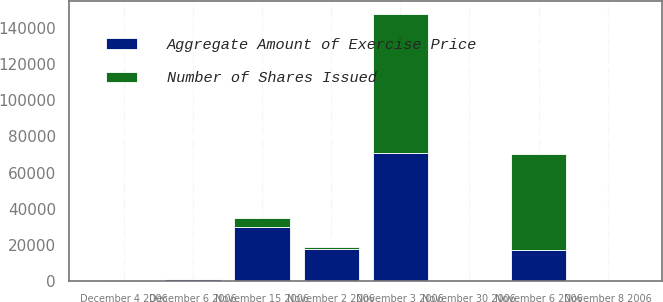<chart> <loc_0><loc_0><loc_500><loc_500><stacked_bar_chart><ecel><fcel>November 2 2006<fcel>November 3 2006<fcel>November 6 2006<fcel>November 8 2006<fcel>November 15 2006<fcel>November 30 2006<fcel>December 4 2006<fcel>December 6 2006<nl><fcel>Aggregate Amount of Exercise Price<fcel>17550<fcel>70750<fcel>17000<fcel>25<fcel>30000<fcel>500<fcel>100<fcel>1000<nl><fcel>Number of Shares Issued<fcel>1000<fcel>76821<fcel>53190<fcel>66<fcel>5000<fcel>83<fcel>265<fcel>167<nl></chart> 